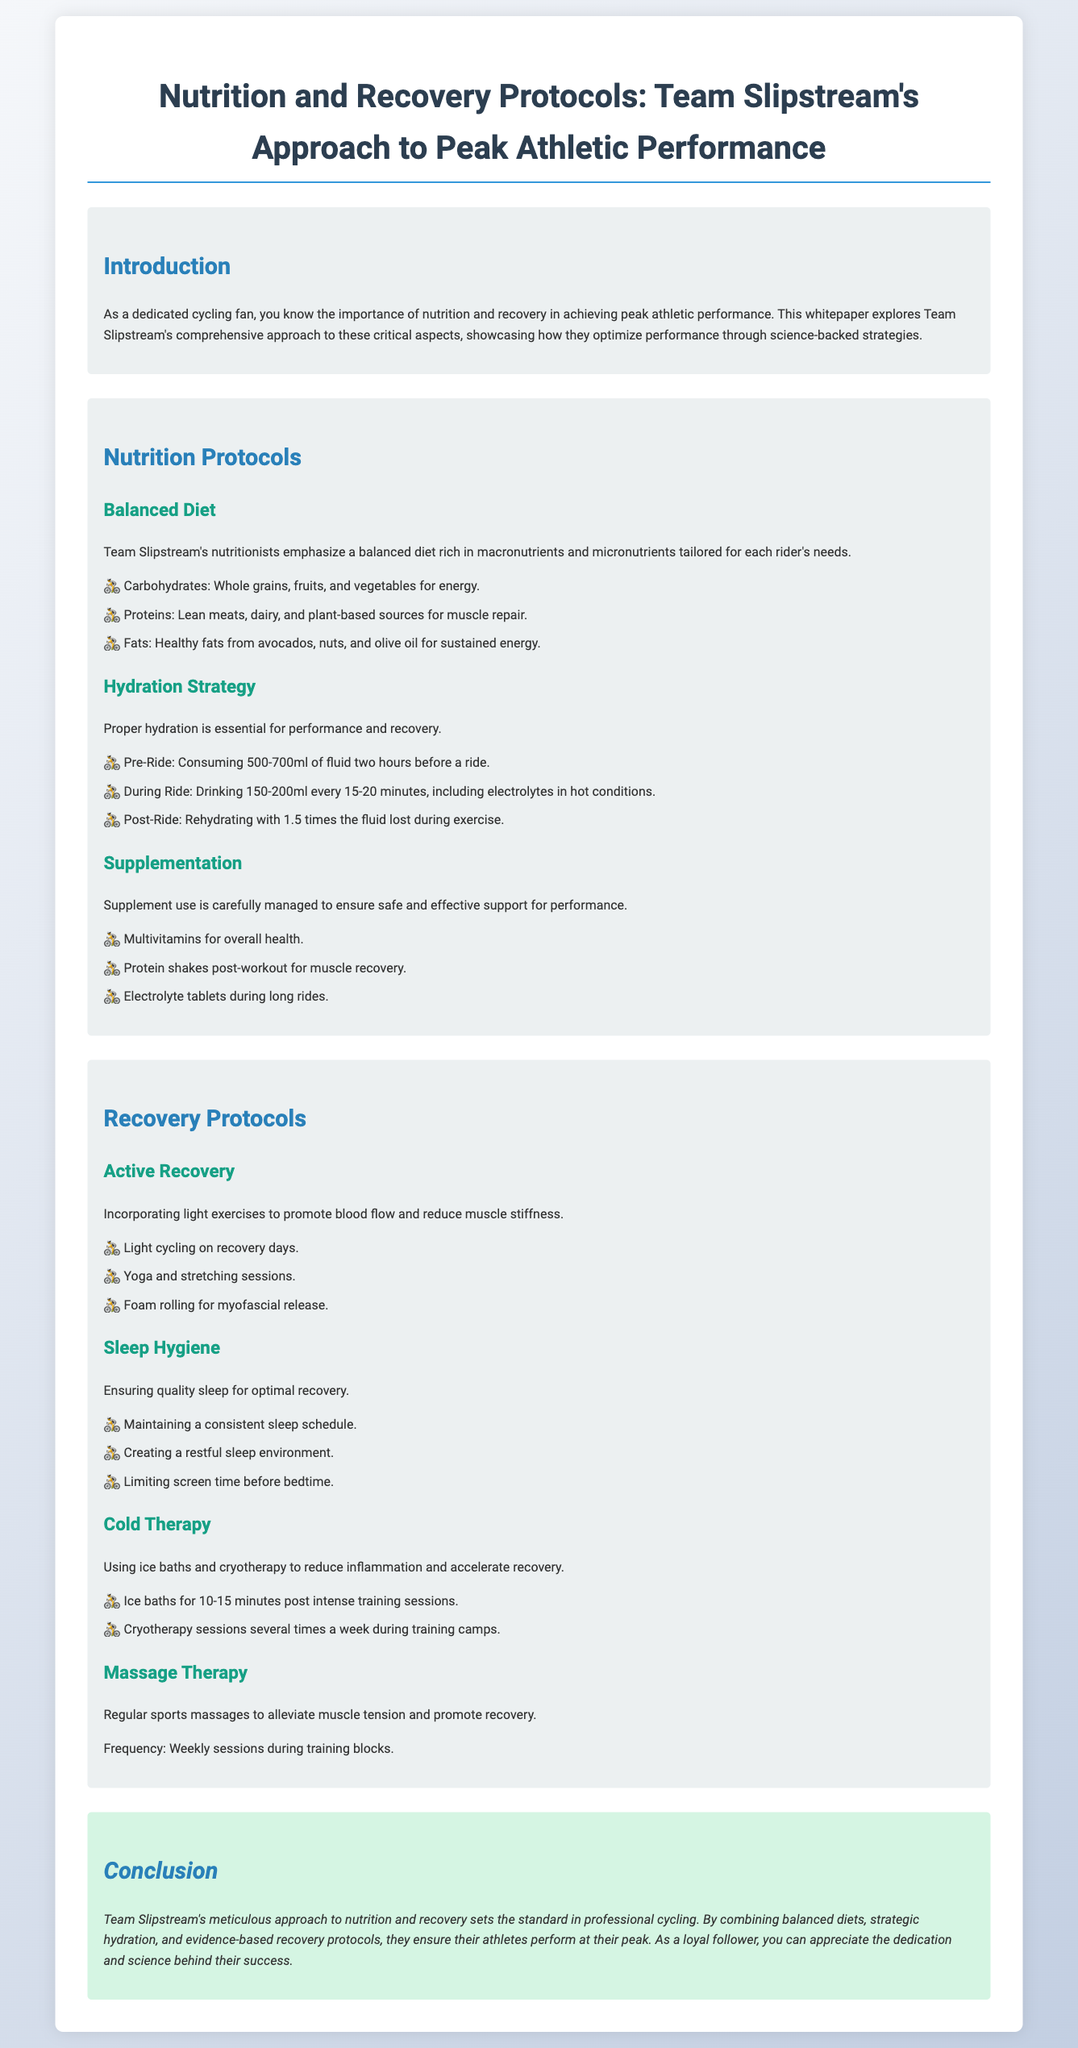What is the main focus of Team Slipstream's whitepaper? The whitepaper focuses on nutrition and recovery protocols aimed at enhancing athletic performance.
Answer: Nutrition and recovery protocols What are the three main components of Team Slipstream's balanced diet? The three components emphasized for a balanced diet include carbohydrates, proteins, and fats.
Answer: Carbohydrates, proteins, and fats How much fluid should riders consume before a ride? Riders are advised to consume 500-700ml of fluid two hours before a ride.
Answer: 500-700ml What type of therapy is suggested for reducing muscle tension? Regular sports massages are suggested for alleviating muscle tension.
Answer: Massage therapy How often should athletes utilize ice baths according to the document? Ice baths should be utilized for 10-15 minutes post intense training sessions.
Answer: 10-15 minutes What practice is mentioned to promote sleep hygiene? Limiting screen time before bedtime is mentioned as a practice for promoting sleep hygiene.
Answer: Limiting screen time What is one form of active recovery recommended? Light cycling on recovery days is recommended as a form of active recovery.
Answer: Light cycling How frequently should massage therapy sessions occur during training blocks? The document states that massage therapy sessions should occur weekly during training blocks.
Answer: Weekly sessions 